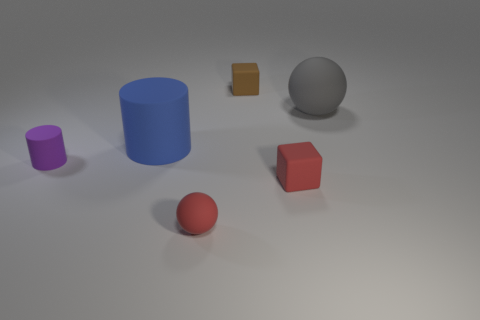Can you describe the texture of the surface on which the objects are placed? The surface appears to be matte with some shadows that suggest a slight texture, possibly indicative of a non-glossy, smooth material. 